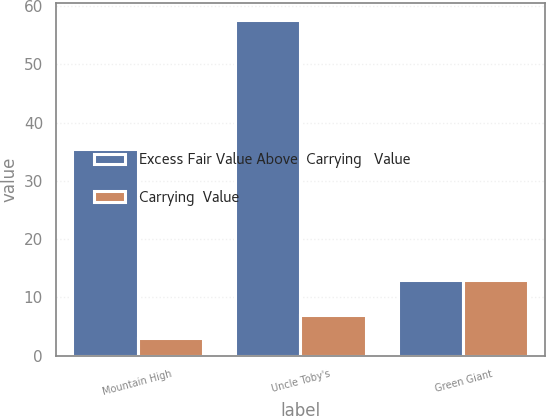Convert chart. <chart><loc_0><loc_0><loc_500><loc_500><stacked_bar_chart><ecel><fcel>Mountain High<fcel>Uncle Toby's<fcel>Green Giant<nl><fcel>Excess Fair Value Above  Carrying   Value<fcel>35.4<fcel>57.7<fcel>13<nl><fcel>Carrying  Value<fcel>3<fcel>7<fcel>13<nl></chart> 